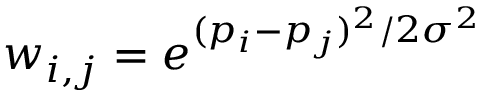<formula> <loc_0><loc_0><loc_500><loc_500>w _ { i , j } = e ^ { ( p _ { i } - p _ { j } ) ^ { 2 } / 2 \sigma ^ { 2 } }</formula> 